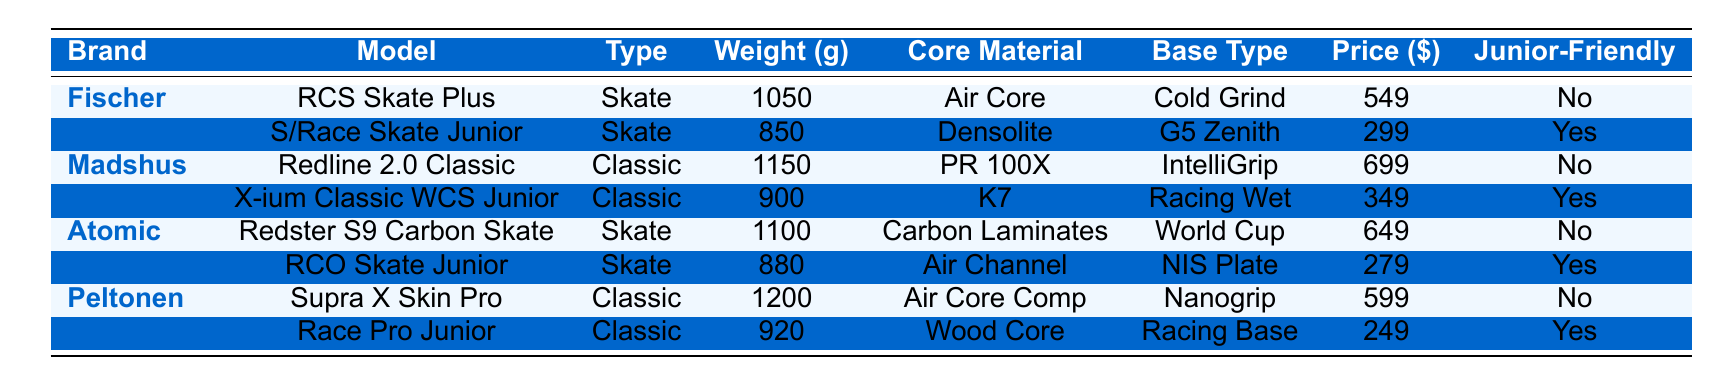What is the lightest model in the table? By examining the weights listed for each model, the lightest model is the Salomon S/Race Skate Junior, which weighs 850 grams.
Answer: 850 grams Which brand has the most expensive model? Looking at the prices of the models, the Madshus Redline 2.0 Classic is the most expensive at $699.
Answer: $699 How many models are junior-friendly? By counting the entries labeled as "Yes" in the Junior-Friendly column, there are four junior-friendly models: Salomon S/Race Skate Junior, Rossignol X-ium Classic WCS Junior, Alpina RCO Skate Junior, and Start Race Pro Junior.
Answer: 4 What is the average weight of the Classic models? The weights for the Classic models are 1150g, 900g, and 1200g. Adding these together gives 1150 + 900 + 1200 = 3250g. Dividing by 3 to find the average results in 3250g / 3 = 1083.33g.
Answer: 1083.33 grams Is there a model that weighs less than 900 grams? By checking the weight of each model, the Salomon S/Race Skate Junior at 850 grams is the only model weighing less than 900 grams.
Answer: Yes Which model offers the lowest price, and what is it? By scanning the prices of all models, the Start Race Pro Junior has the lowest price at $249.
Answer: $249 What is the total weight of all Skate models? The Skate models are Fischer RCS Skate Plus (1050g), Salomon S/Race Skate Junior (850g), Atomic Redster S9 Carbon Skate (1100g), and Alpina RCO Skate Junior (880g). Adding these weights gives 1050 + 850 + 1100 + 880 = 3880g.
Answer: 3880 grams Which model has the heaviest weight, and what is its price? The heaviest model is the Peltonen Supra X Skin Pro, weighing 1200 grams, and its price is $599.
Answer: 1200 grams, $599 How many models are classified as 'Skate' and are junior-friendly? Checking the "Junior-Friendly" column for Skate models, only the Salomon S/Race Skate Junior and Alpina RCO Skate Junior are junior-friendly, giving a total of 2 models.
Answer: 2 What is the price difference between the most expensive and the cheapest model on the list? The most expensive model is the Madshus Redline 2.0 Classic at $699, and the cheapest is the Start Race Pro Junior at $249. The price difference is $699 - $249 = $450.
Answer: $450 